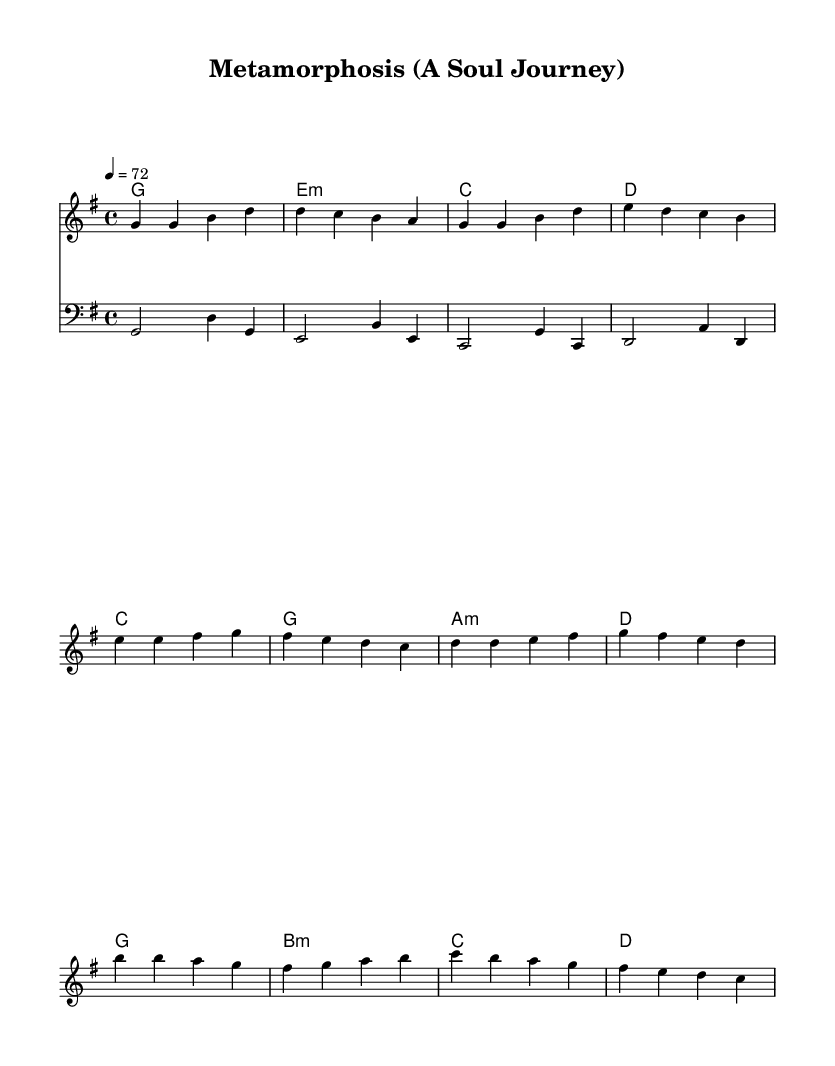What is the key signature of this music? The key signature is indicated by the number of sharps or flats at the beginning of the staff. In this case, there are no sharps or flats listed, which corresponds to the key of G major.
Answer: G major What is the time signature of this music? The time signature is found at the beginning of the staff, showing how many beats are in each measure. Here, the time signature is 4/4, meaning there are four beats per measure and the quarter note gets one beat.
Answer: 4/4 What is the tempo marking for this piece? The tempo is indicated at the beginning of the music with the term and numeric value. In this score, it is marked as "4 = 72," indicating a moderate tempo where the quarter note equals 72 beats per minute.
Answer: 72 How many measures are in the verse section? By looking at the melody notations, the verse consists of four distinct measures before transitioning to the pre-chorus. Therefore, the total number of measures in the verse section is counted as four.
Answer: 4 What chords are used in the chorus? The chorus section's chords are listed under the chord names in the score. They are identified as G major, B minor, C major, and D major, indicating the harmonic structure played during this part.
Answer: G, B minor, C, D What type of musical form is primarily used in this piece? Analyzing the sections of the music, it follows a familiar structure where verses, pre-chorus, and chorus are repeated, characteristic of the soul genres, indicating a verse-chorus form.
Answer: Verse-Chorus Which clef is used for the bass line? The bass line of the score is introduced with a specific clef sign at the beginning, which in this case is the bass clef, indicating that it is meant to be played by lower-pitched instruments.
Answer: Bass clef 